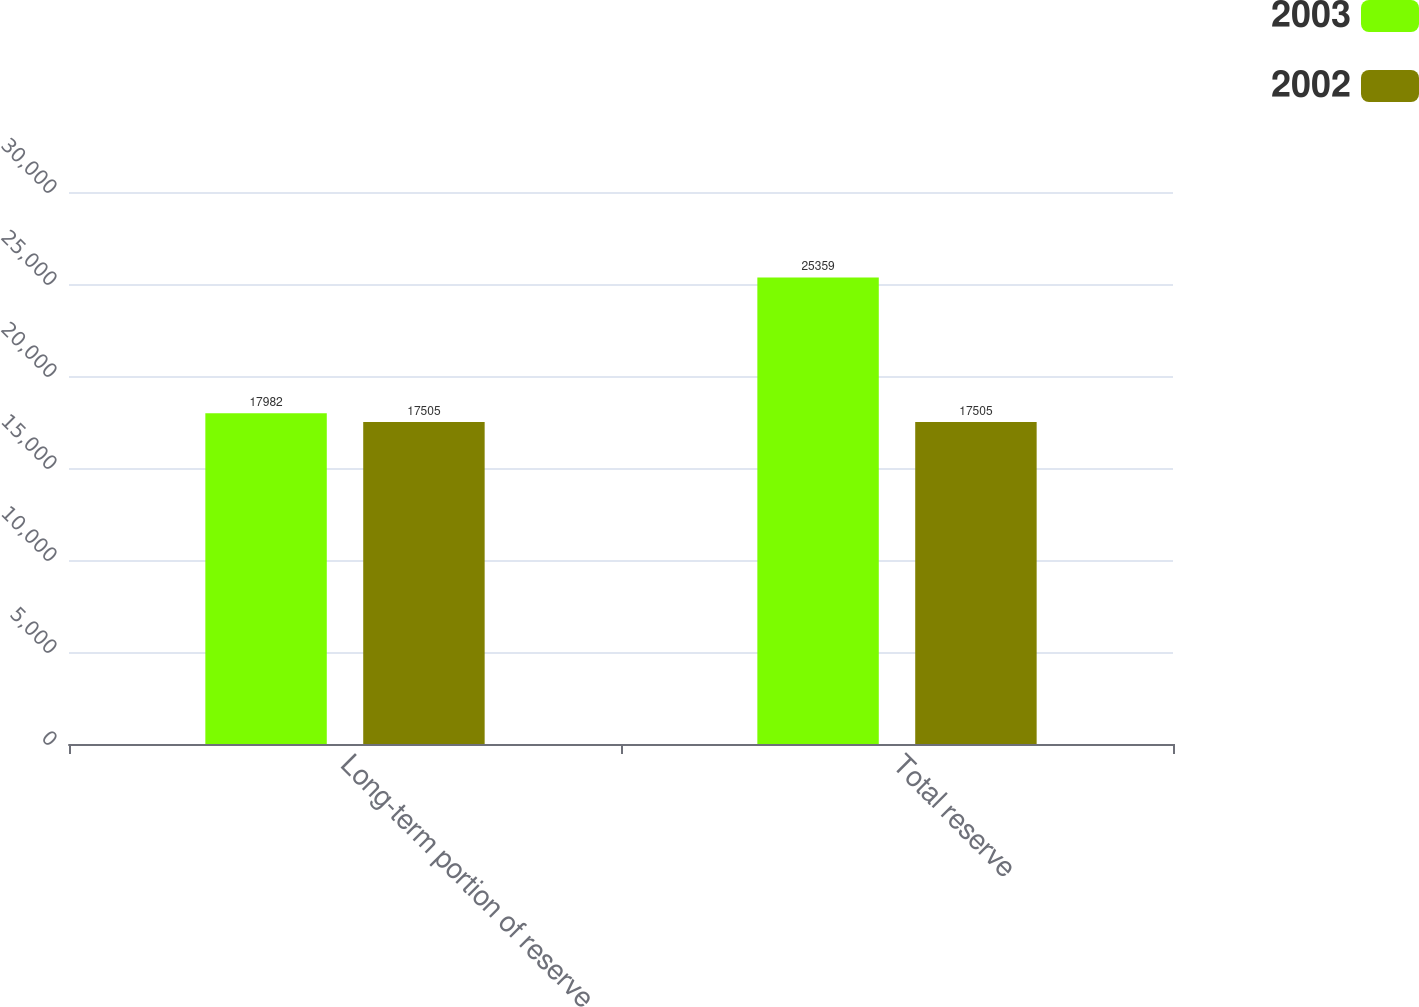Convert chart. <chart><loc_0><loc_0><loc_500><loc_500><stacked_bar_chart><ecel><fcel>Long-term portion of reserve<fcel>Total reserve<nl><fcel>2003<fcel>17982<fcel>25359<nl><fcel>2002<fcel>17505<fcel>17505<nl></chart> 